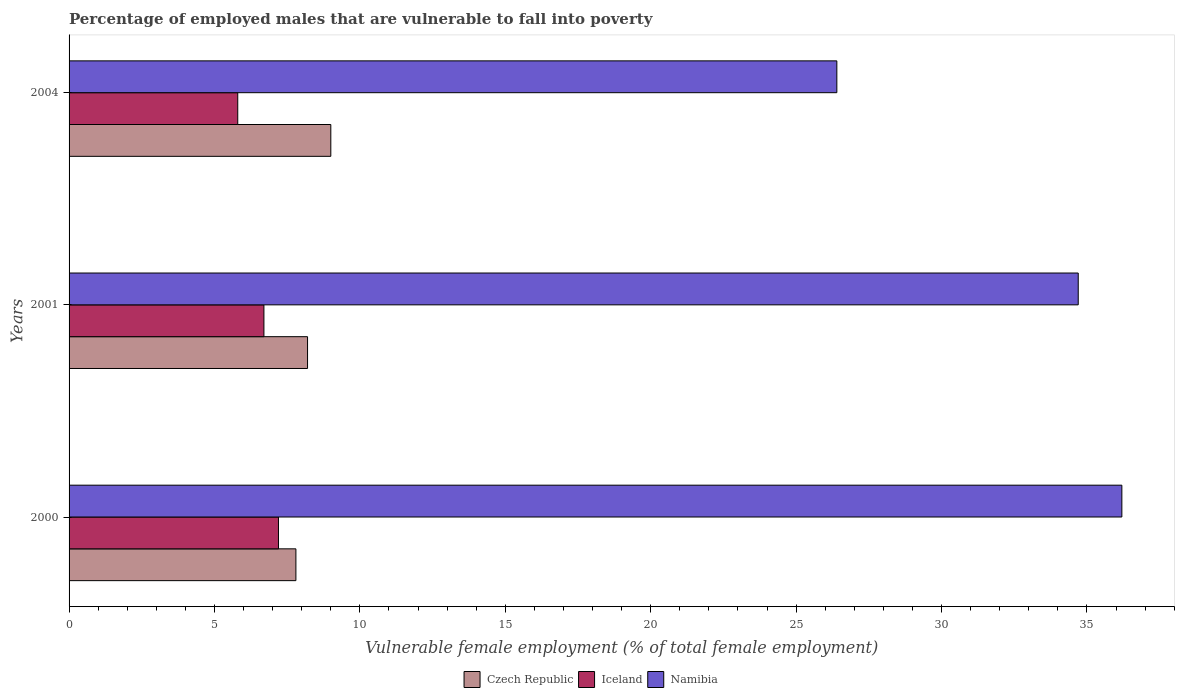How many groups of bars are there?
Make the answer very short. 3. Are the number of bars per tick equal to the number of legend labels?
Provide a succinct answer. Yes. How many bars are there on the 1st tick from the bottom?
Offer a terse response. 3. In how many cases, is the number of bars for a given year not equal to the number of legend labels?
Your answer should be very brief. 0. What is the percentage of employed males who are vulnerable to fall into poverty in Namibia in 2004?
Keep it short and to the point. 26.4. Across all years, what is the maximum percentage of employed males who are vulnerable to fall into poverty in Iceland?
Your answer should be compact. 7.2. Across all years, what is the minimum percentage of employed males who are vulnerable to fall into poverty in Czech Republic?
Give a very brief answer. 7.8. In which year was the percentage of employed males who are vulnerable to fall into poverty in Czech Republic maximum?
Your response must be concise. 2004. In which year was the percentage of employed males who are vulnerable to fall into poverty in Namibia minimum?
Give a very brief answer. 2004. What is the total percentage of employed males who are vulnerable to fall into poverty in Namibia in the graph?
Make the answer very short. 97.3. What is the difference between the percentage of employed males who are vulnerable to fall into poverty in Namibia in 2001 and that in 2004?
Your response must be concise. 8.3. What is the difference between the percentage of employed males who are vulnerable to fall into poverty in Namibia in 2004 and the percentage of employed males who are vulnerable to fall into poverty in Iceland in 2000?
Offer a very short reply. 19.2. What is the average percentage of employed males who are vulnerable to fall into poverty in Iceland per year?
Your response must be concise. 6.57. In the year 2000, what is the difference between the percentage of employed males who are vulnerable to fall into poverty in Iceland and percentage of employed males who are vulnerable to fall into poverty in Czech Republic?
Make the answer very short. -0.6. What is the ratio of the percentage of employed males who are vulnerable to fall into poverty in Czech Republic in 2001 to that in 2004?
Offer a very short reply. 0.91. Is the difference between the percentage of employed males who are vulnerable to fall into poverty in Iceland in 2001 and 2004 greater than the difference between the percentage of employed males who are vulnerable to fall into poverty in Czech Republic in 2001 and 2004?
Provide a succinct answer. Yes. What is the difference between the highest and the second highest percentage of employed males who are vulnerable to fall into poverty in Namibia?
Make the answer very short. 1.5. What is the difference between the highest and the lowest percentage of employed males who are vulnerable to fall into poverty in Namibia?
Your answer should be compact. 9.8. Is the sum of the percentage of employed males who are vulnerable to fall into poverty in Czech Republic in 2000 and 2001 greater than the maximum percentage of employed males who are vulnerable to fall into poverty in Iceland across all years?
Ensure brevity in your answer.  Yes. What does the 1st bar from the top in 2000 represents?
Your answer should be compact. Namibia. What does the 2nd bar from the bottom in 2001 represents?
Offer a terse response. Iceland. How many years are there in the graph?
Keep it short and to the point. 3. Does the graph contain grids?
Your answer should be compact. No. How many legend labels are there?
Offer a very short reply. 3. How are the legend labels stacked?
Make the answer very short. Horizontal. What is the title of the graph?
Ensure brevity in your answer.  Percentage of employed males that are vulnerable to fall into poverty. Does "Cayman Islands" appear as one of the legend labels in the graph?
Keep it short and to the point. No. What is the label or title of the X-axis?
Your response must be concise. Vulnerable female employment (% of total female employment). What is the label or title of the Y-axis?
Provide a short and direct response. Years. What is the Vulnerable female employment (% of total female employment) in Czech Republic in 2000?
Offer a very short reply. 7.8. What is the Vulnerable female employment (% of total female employment) in Iceland in 2000?
Offer a terse response. 7.2. What is the Vulnerable female employment (% of total female employment) of Namibia in 2000?
Your answer should be very brief. 36.2. What is the Vulnerable female employment (% of total female employment) of Czech Republic in 2001?
Make the answer very short. 8.2. What is the Vulnerable female employment (% of total female employment) of Iceland in 2001?
Offer a terse response. 6.7. What is the Vulnerable female employment (% of total female employment) in Namibia in 2001?
Keep it short and to the point. 34.7. What is the Vulnerable female employment (% of total female employment) of Iceland in 2004?
Your answer should be very brief. 5.8. What is the Vulnerable female employment (% of total female employment) in Namibia in 2004?
Ensure brevity in your answer.  26.4. Across all years, what is the maximum Vulnerable female employment (% of total female employment) of Czech Republic?
Offer a very short reply. 9. Across all years, what is the maximum Vulnerable female employment (% of total female employment) of Iceland?
Provide a short and direct response. 7.2. Across all years, what is the maximum Vulnerable female employment (% of total female employment) in Namibia?
Your answer should be very brief. 36.2. Across all years, what is the minimum Vulnerable female employment (% of total female employment) in Czech Republic?
Your response must be concise. 7.8. Across all years, what is the minimum Vulnerable female employment (% of total female employment) of Iceland?
Give a very brief answer. 5.8. Across all years, what is the minimum Vulnerable female employment (% of total female employment) in Namibia?
Make the answer very short. 26.4. What is the total Vulnerable female employment (% of total female employment) of Czech Republic in the graph?
Your answer should be very brief. 25. What is the total Vulnerable female employment (% of total female employment) of Iceland in the graph?
Your response must be concise. 19.7. What is the total Vulnerable female employment (% of total female employment) of Namibia in the graph?
Offer a terse response. 97.3. What is the difference between the Vulnerable female employment (% of total female employment) of Namibia in 2000 and that in 2001?
Give a very brief answer. 1.5. What is the difference between the Vulnerable female employment (% of total female employment) of Czech Republic in 2000 and that in 2004?
Make the answer very short. -1.2. What is the difference between the Vulnerable female employment (% of total female employment) in Namibia in 2000 and that in 2004?
Provide a succinct answer. 9.8. What is the difference between the Vulnerable female employment (% of total female employment) of Czech Republic in 2001 and that in 2004?
Ensure brevity in your answer.  -0.8. What is the difference between the Vulnerable female employment (% of total female employment) of Iceland in 2001 and that in 2004?
Keep it short and to the point. 0.9. What is the difference between the Vulnerable female employment (% of total female employment) in Namibia in 2001 and that in 2004?
Provide a succinct answer. 8.3. What is the difference between the Vulnerable female employment (% of total female employment) in Czech Republic in 2000 and the Vulnerable female employment (% of total female employment) in Iceland in 2001?
Ensure brevity in your answer.  1.1. What is the difference between the Vulnerable female employment (% of total female employment) in Czech Republic in 2000 and the Vulnerable female employment (% of total female employment) in Namibia in 2001?
Your answer should be very brief. -26.9. What is the difference between the Vulnerable female employment (% of total female employment) of Iceland in 2000 and the Vulnerable female employment (% of total female employment) of Namibia in 2001?
Make the answer very short. -27.5. What is the difference between the Vulnerable female employment (% of total female employment) of Czech Republic in 2000 and the Vulnerable female employment (% of total female employment) of Namibia in 2004?
Make the answer very short. -18.6. What is the difference between the Vulnerable female employment (% of total female employment) in Iceland in 2000 and the Vulnerable female employment (% of total female employment) in Namibia in 2004?
Make the answer very short. -19.2. What is the difference between the Vulnerable female employment (% of total female employment) in Czech Republic in 2001 and the Vulnerable female employment (% of total female employment) in Iceland in 2004?
Give a very brief answer. 2.4. What is the difference between the Vulnerable female employment (% of total female employment) in Czech Republic in 2001 and the Vulnerable female employment (% of total female employment) in Namibia in 2004?
Give a very brief answer. -18.2. What is the difference between the Vulnerable female employment (% of total female employment) in Iceland in 2001 and the Vulnerable female employment (% of total female employment) in Namibia in 2004?
Ensure brevity in your answer.  -19.7. What is the average Vulnerable female employment (% of total female employment) of Czech Republic per year?
Your answer should be compact. 8.33. What is the average Vulnerable female employment (% of total female employment) in Iceland per year?
Keep it short and to the point. 6.57. What is the average Vulnerable female employment (% of total female employment) in Namibia per year?
Give a very brief answer. 32.43. In the year 2000, what is the difference between the Vulnerable female employment (% of total female employment) of Czech Republic and Vulnerable female employment (% of total female employment) of Namibia?
Provide a short and direct response. -28.4. In the year 2001, what is the difference between the Vulnerable female employment (% of total female employment) of Czech Republic and Vulnerable female employment (% of total female employment) of Iceland?
Your response must be concise. 1.5. In the year 2001, what is the difference between the Vulnerable female employment (% of total female employment) in Czech Republic and Vulnerable female employment (% of total female employment) in Namibia?
Your answer should be compact. -26.5. In the year 2001, what is the difference between the Vulnerable female employment (% of total female employment) in Iceland and Vulnerable female employment (% of total female employment) in Namibia?
Offer a terse response. -28. In the year 2004, what is the difference between the Vulnerable female employment (% of total female employment) in Czech Republic and Vulnerable female employment (% of total female employment) in Iceland?
Ensure brevity in your answer.  3.2. In the year 2004, what is the difference between the Vulnerable female employment (% of total female employment) in Czech Republic and Vulnerable female employment (% of total female employment) in Namibia?
Your response must be concise. -17.4. In the year 2004, what is the difference between the Vulnerable female employment (% of total female employment) of Iceland and Vulnerable female employment (% of total female employment) of Namibia?
Your answer should be very brief. -20.6. What is the ratio of the Vulnerable female employment (% of total female employment) in Czech Republic in 2000 to that in 2001?
Offer a terse response. 0.95. What is the ratio of the Vulnerable female employment (% of total female employment) in Iceland in 2000 to that in 2001?
Provide a succinct answer. 1.07. What is the ratio of the Vulnerable female employment (% of total female employment) in Namibia in 2000 to that in 2001?
Keep it short and to the point. 1.04. What is the ratio of the Vulnerable female employment (% of total female employment) in Czech Republic in 2000 to that in 2004?
Keep it short and to the point. 0.87. What is the ratio of the Vulnerable female employment (% of total female employment) of Iceland in 2000 to that in 2004?
Make the answer very short. 1.24. What is the ratio of the Vulnerable female employment (% of total female employment) in Namibia in 2000 to that in 2004?
Offer a terse response. 1.37. What is the ratio of the Vulnerable female employment (% of total female employment) of Czech Republic in 2001 to that in 2004?
Keep it short and to the point. 0.91. What is the ratio of the Vulnerable female employment (% of total female employment) of Iceland in 2001 to that in 2004?
Make the answer very short. 1.16. What is the ratio of the Vulnerable female employment (% of total female employment) of Namibia in 2001 to that in 2004?
Your answer should be very brief. 1.31. What is the difference between the highest and the second highest Vulnerable female employment (% of total female employment) of Czech Republic?
Give a very brief answer. 0.8. What is the difference between the highest and the lowest Vulnerable female employment (% of total female employment) in Czech Republic?
Offer a very short reply. 1.2. What is the difference between the highest and the lowest Vulnerable female employment (% of total female employment) in Namibia?
Offer a very short reply. 9.8. 